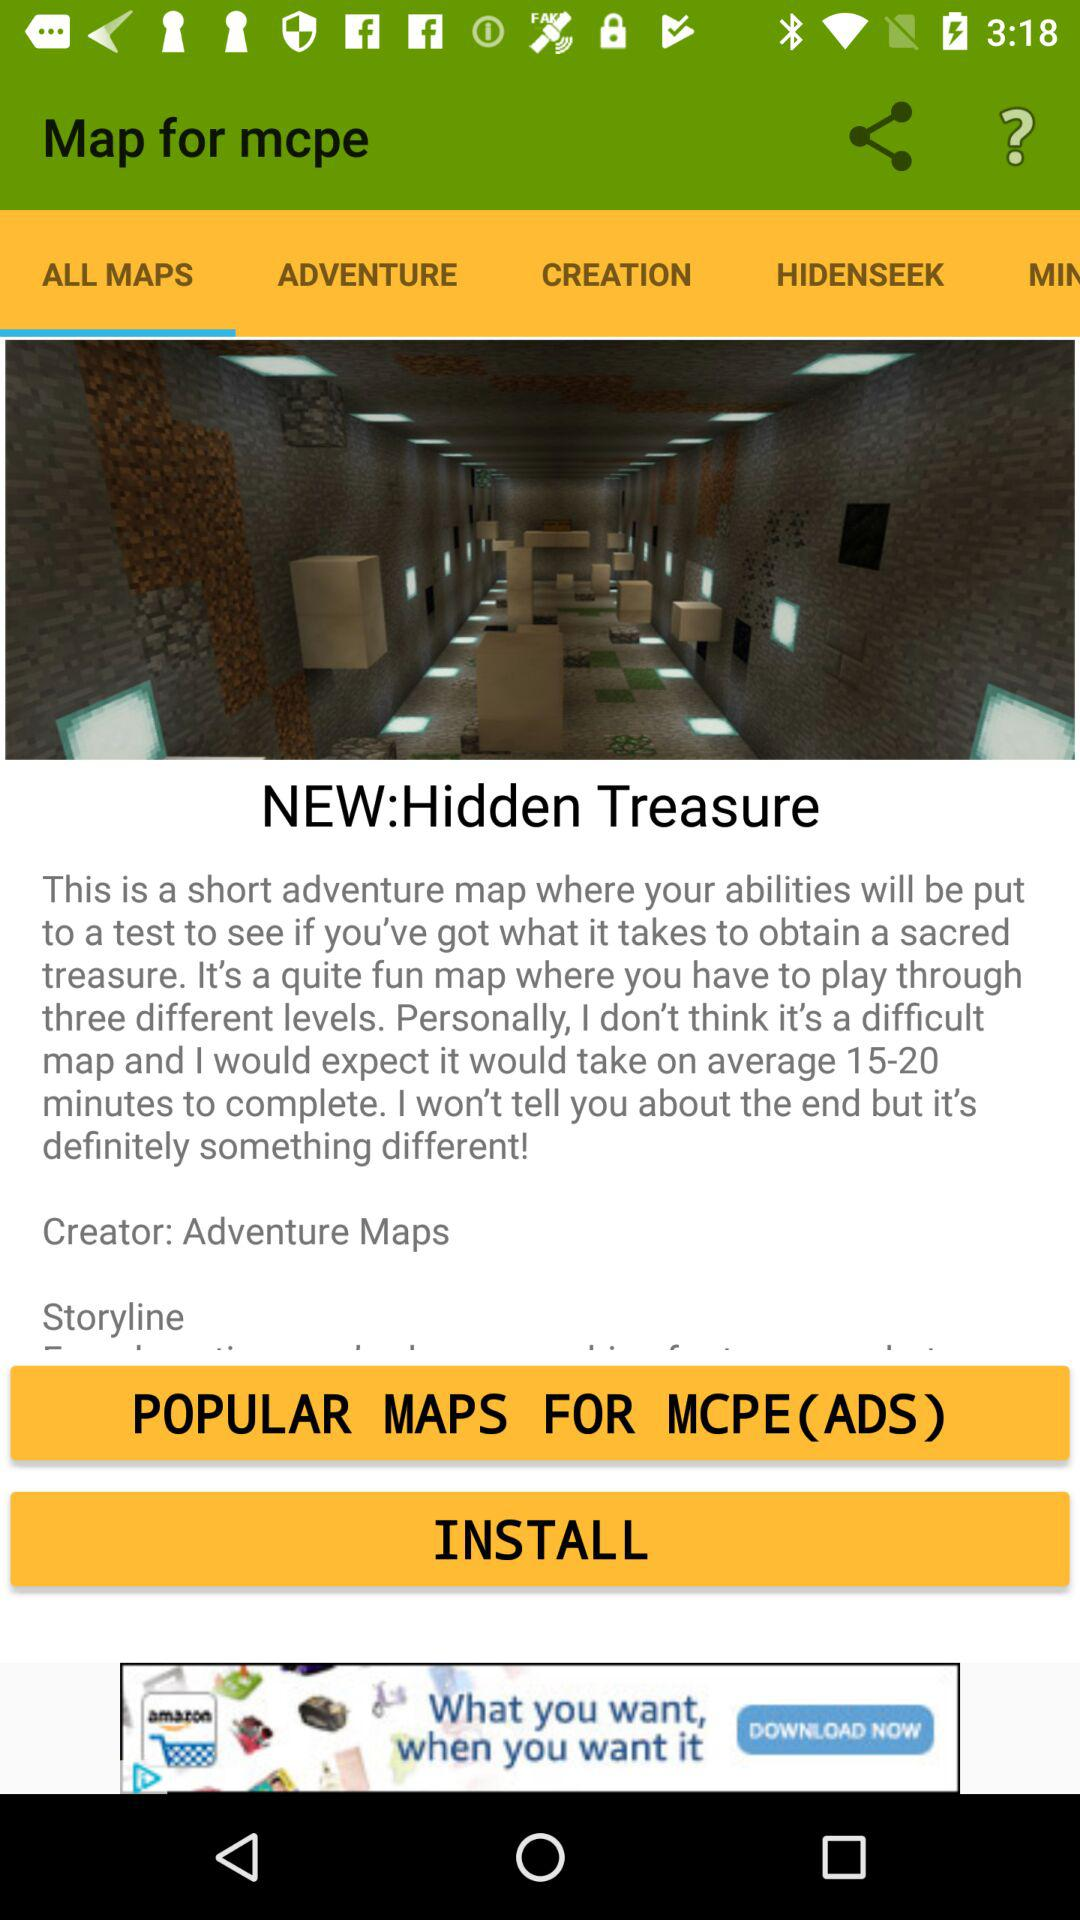Who is the creator? The creator is "Adventure Maps". 